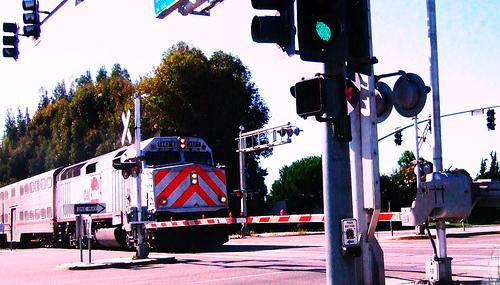Are the lights on the train on?
Short answer required. Yes. Where are the orange stripes?
Quick response, please. Front of train. Is this a railroad crossing?
Write a very short answer. Yes. 